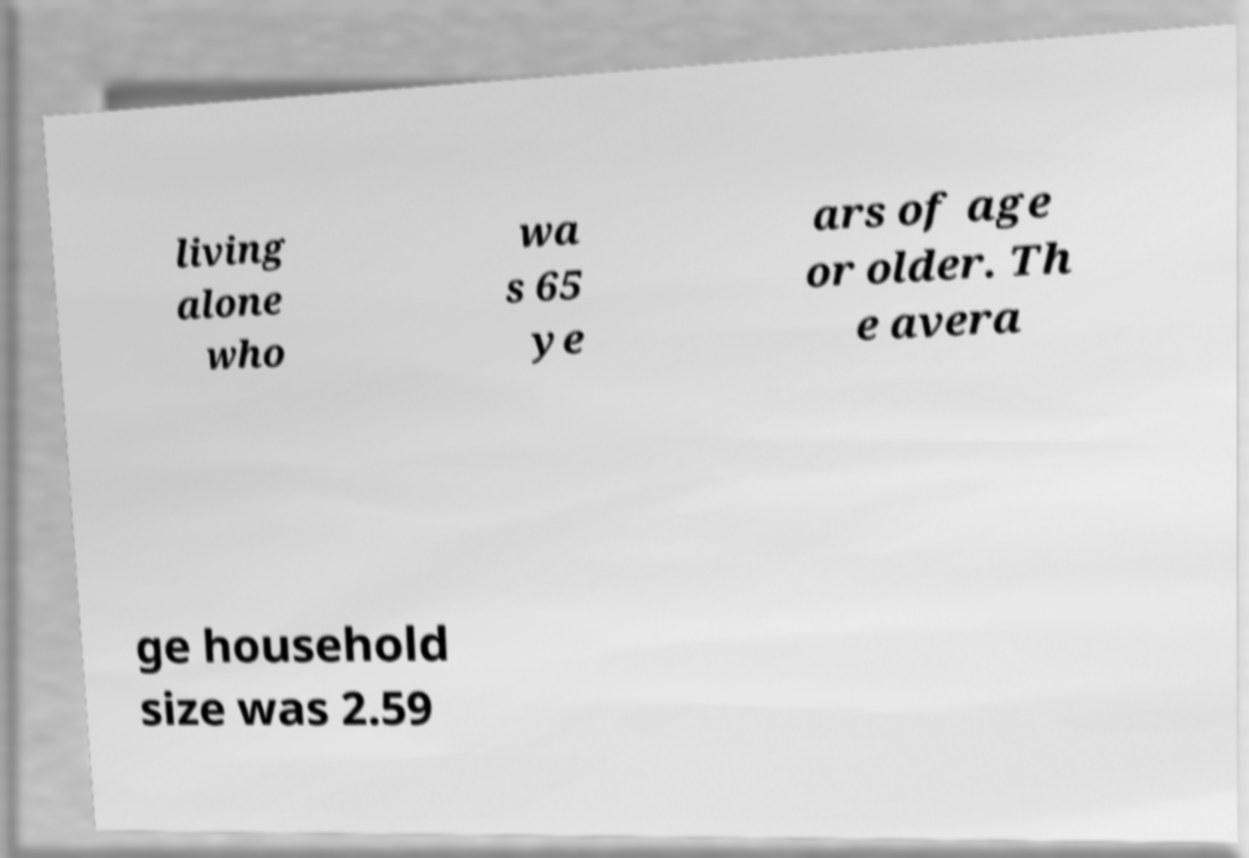Please read and relay the text visible in this image. What does it say? living alone who wa s 65 ye ars of age or older. Th e avera ge household size was 2.59 